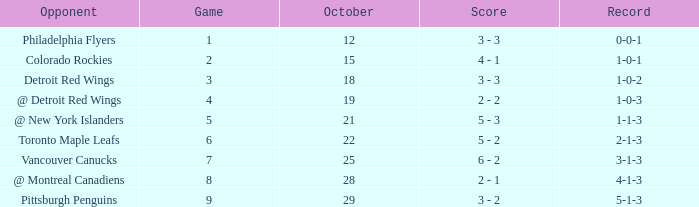Name the most october for game less than 1 None. 